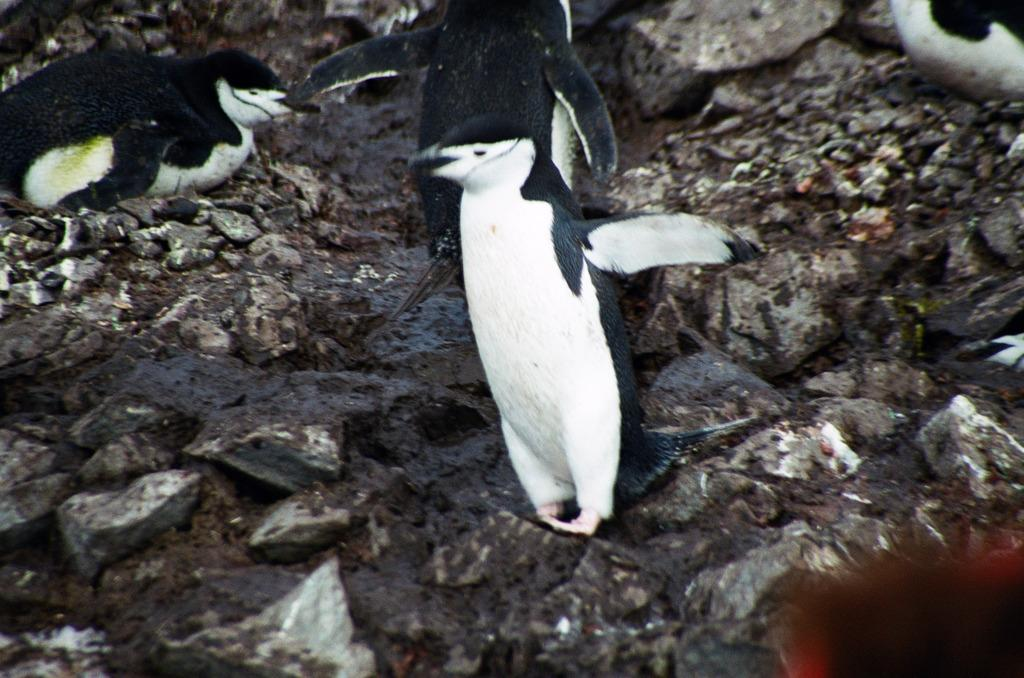What type of animals are present in the image? There are penguins in the image. Where are the penguins located? The penguins are on a surface. What type of furniture is present in the bedroom in the image? There is no bedroom or furniture present in the image; it features penguins on a surface. What country does the representative in the image come from? There is no representative present in the image; it features penguins on a surface. 